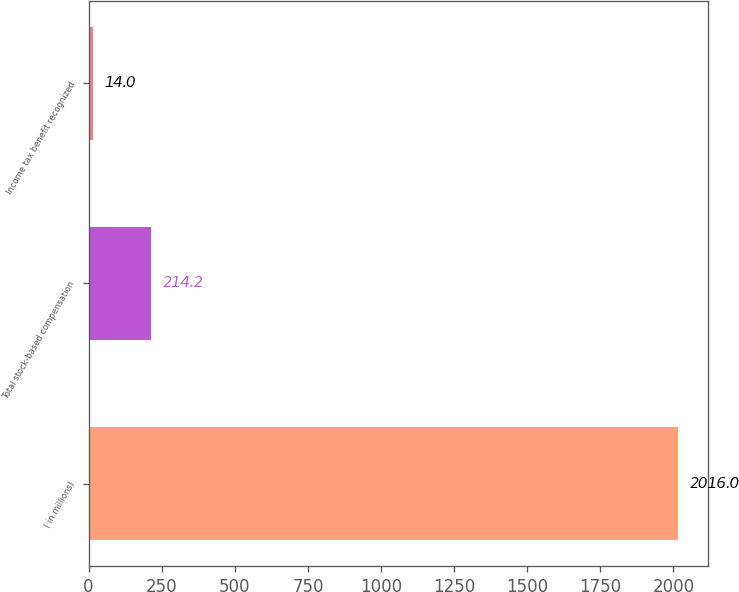<chart> <loc_0><loc_0><loc_500><loc_500><bar_chart><fcel>( in millions)<fcel>Total stock-based compensation<fcel>Income tax benefit recognized<nl><fcel>2016<fcel>214.2<fcel>14<nl></chart> 